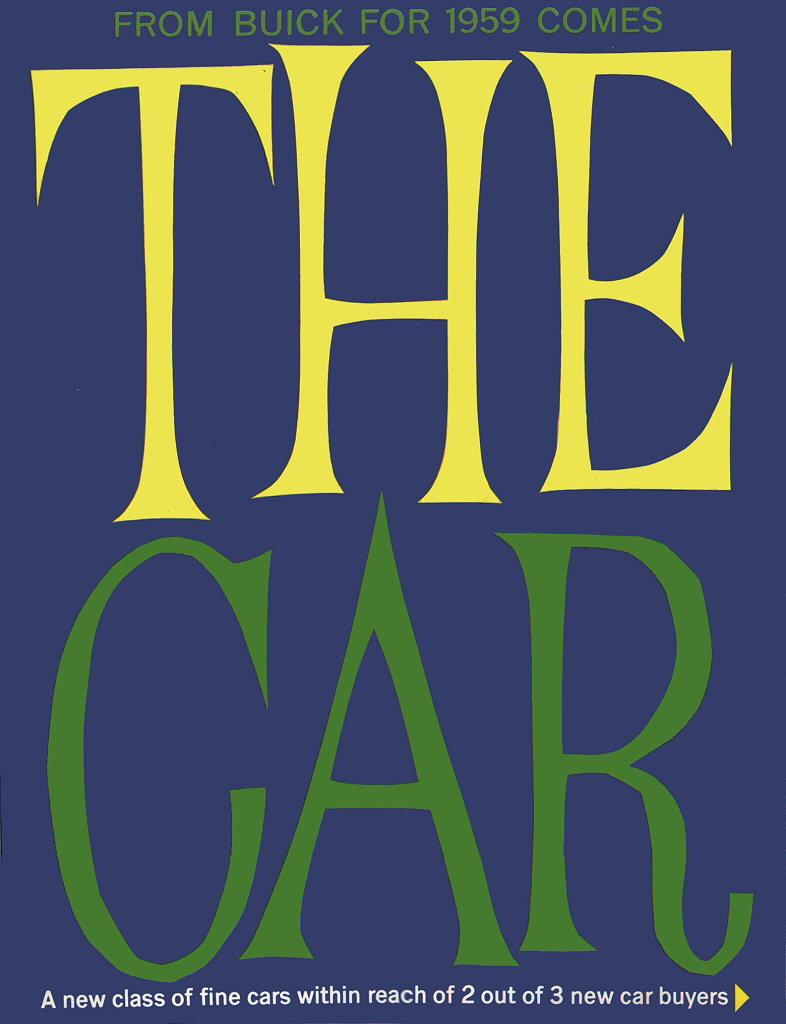What year is listed on this title?
Offer a very short reply. 1959. What is the title of the work shown?
Your answer should be very brief. The car. 